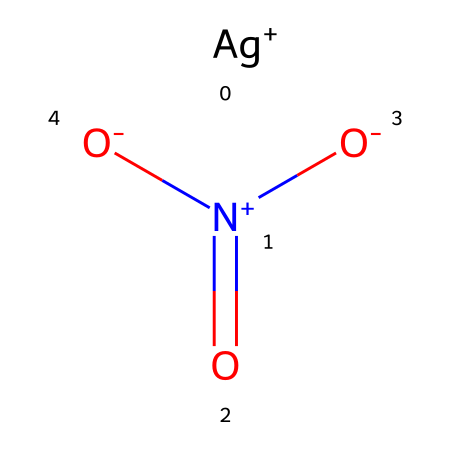What is the total number of oxygen atoms in this compound? By examining the SMILES representation, we see three oxygen atoms (from the three [O] elements connected to the nitrogen).
Answer: three What is the central atom in this chemical structure? In the SMILES, the nitrogen atom (denoted by [N]) is the central atom, as it is bonded to multiple oxygen atoms and is part of the nitrate group.
Answer: nitrogen What charge does silver carry in this compound? The SMILES notation indicates that silver is represented as [Ag+], which shows it carries a positive charge.
Answer: positive How many nitrogen-oxygen bonds are present in this compound? Analyzing the bonding, we see that there are three bonds between nitrogen and oxygen due to the three oxygen atoms bonded to the nitrogen.
Answer: three Is this chemical considered a herbicide? Silver nitrate is primarily known for its use in photography but also has applications in agriculture and pest control, indicating its potential use as a herbicide.
Answer: yes What type of chemical is silver nitrate classified as? Silver nitrate, based on its structure characterized by the silver ion and nitrate group, is classified as an inorganic salt.
Answer: inorganic salt What is the geometric shape around the nitrogen atom in this compound? The nitrogen atom is bonded to three oxygen atoms, which generally leads to a trigonal planar shape due to its hybridization and bonding arrangements.
Answer: trigonal planar 